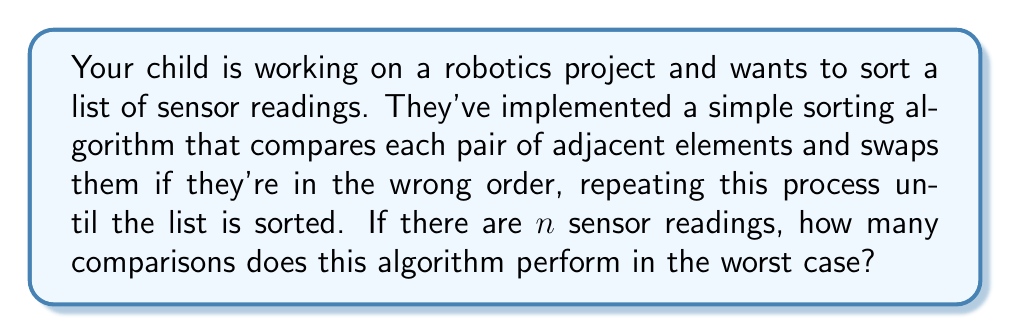Give your solution to this math problem. Let's break this down step-by-step:

1) The algorithm your child is using is called Bubble Sort.

2) In Bubble Sort, we make multiple passes through the list:
   - In the first pass, we compare $n-1$ pairs of elements.
   - In the second pass, we compare $n-2$ pairs.
   - This continues until the last pass, where we compare just 1 pair.

3) The total number of comparisons is the sum of these:
   $$(n-1) + (n-2) + (n-3) + ... + 2 + 1$$

4) This is an arithmetic sequence with $n-1$ terms. The sum of an arithmetic sequence is given by:
   $$S = \frac{n(a_1 + a_n)}{2}$$
   where $n$ is the number of terms, $a_1$ is the first term, and $a_n$ is the last term.

5) In our case:
   - Number of terms = $n-1$
   - First term $a_1 = n-1$
   - Last term $a_n = 1$

6) Plugging these into the formula:
   $$S = \frac{(n-1)((n-1) + 1)}{2} = \frac{(n-1)n}{2}$$

7) This simplifies to:
   $$S = \frac{n^2 - n}{2}$$

8) In big O notation, we focus on the highest order term and drop constants. The highest order term here is $n^2$.

Therefore, the time complexity of this algorithm in the worst case is $O(n^2)$.
Answer: $O(n^2)$ 